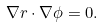Convert formula to latex. <formula><loc_0><loc_0><loc_500><loc_500>\nabla r \cdot \nabla \phi = 0 .</formula> 